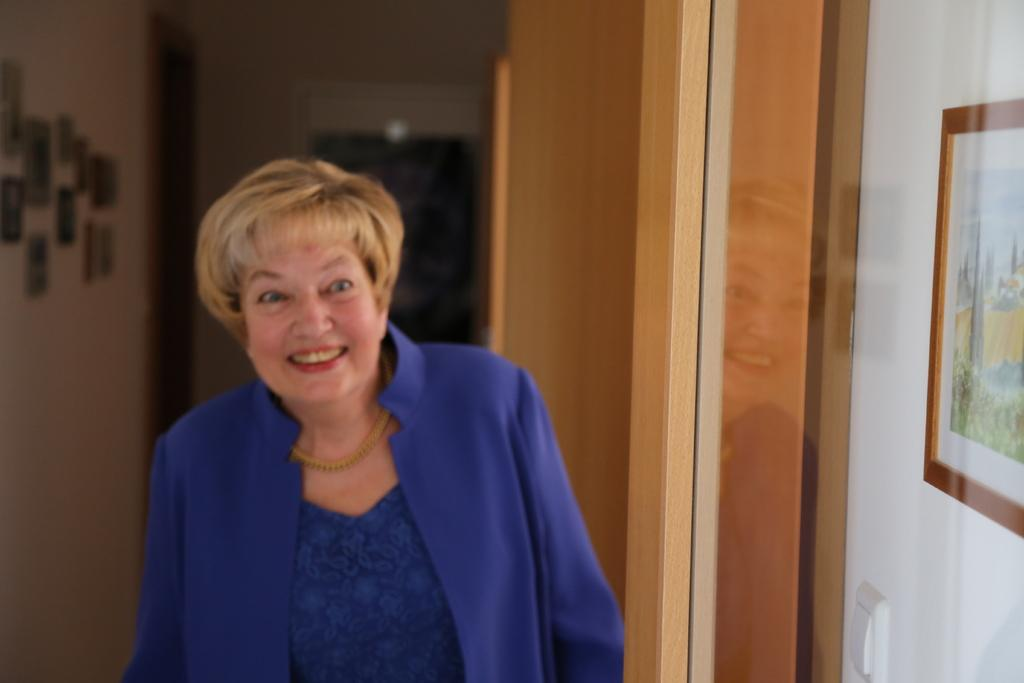Who is present in the image? There is a woman in the image. What can be seen on the right side of the image? There is a photo frame and a door on the right side of the image. What is on the left side of the image? There are photo frames hanged on the left side of the image. Where are the photo frames located? The photo frames are attached to a wall. What is the profit margin of the skin products displayed in the photo frames? There are no skin products or any reference to profit margins in the image; it only features a woman, photo frames, a door, and a wall. 